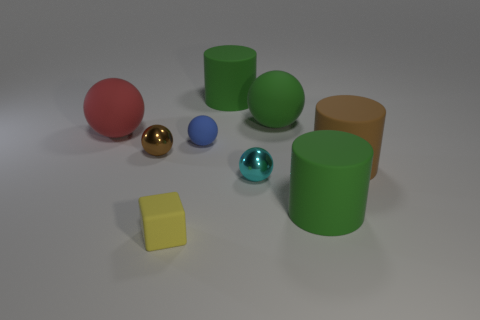Subtract all metal balls. How many balls are left? 3 Subtract all brown cylinders. How many cylinders are left? 2 Subtract 1 blocks. How many blocks are left? 0 Subtract all cyan balls. How many purple cubes are left? 0 Add 1 tiny yellow objects. How many objects exist? 10 Subtract all cylinders. How many objects are left? 6 Subtract all blue balls. Subtract all purple blocks. How many balls are left? 4 Subtract all red matte objects. Subtract all green cylinders. How many objects are left? 6 Add 4 small blue things. How many small blue things are left? 5 Add 5 large matte blocks. How many large matte blocks exist? 5 